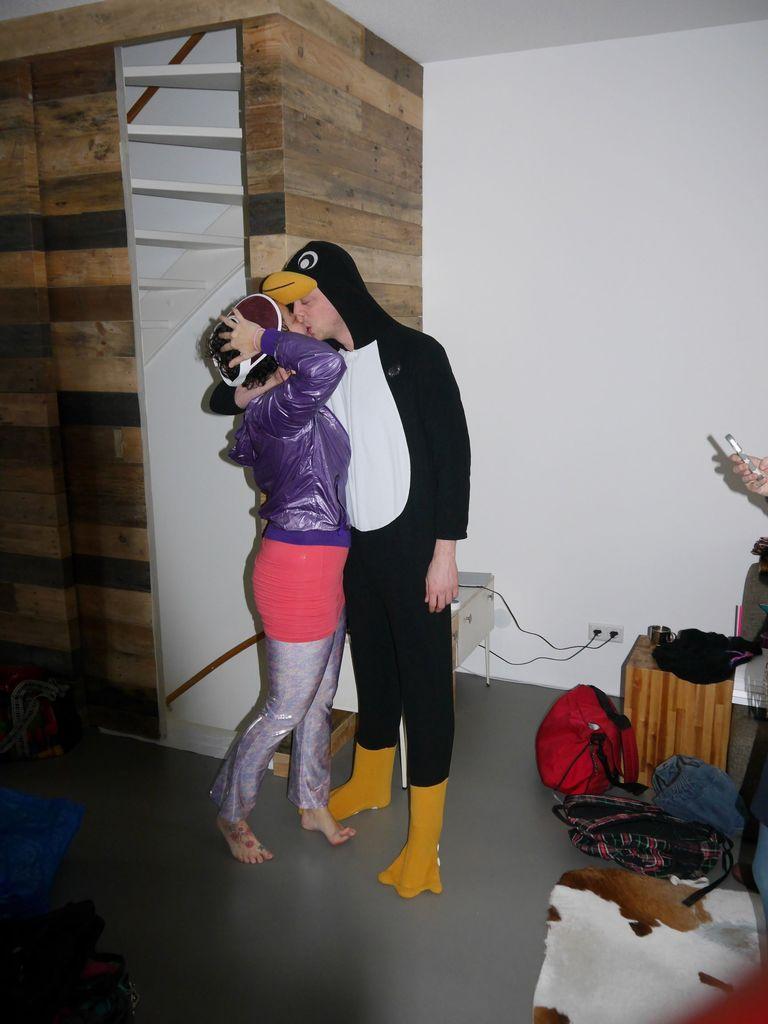In one or two sentences, can you explain what this image depicts? 2 people are standing in a room and kissing each other. The person at the right is wearing a penguin costume. Behind them there is white wall which has sockets and 2 wires are plugged in. There are clothes and other objects at the right and there is a hand of a person. At the left back there are stairs. 